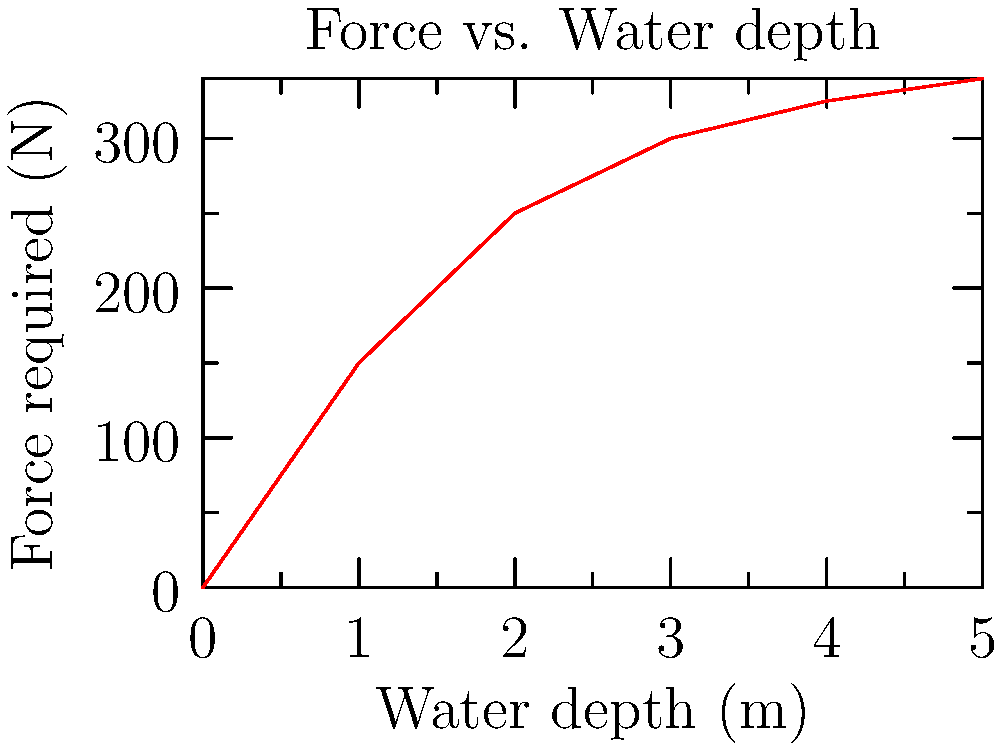Based on the graph showing the relationship between water depth and force required to operate a manual water pump, estimate the additional force needed to pump water from a depth of 4m compared to 2m. How might this information influence your decision-making in water conservation efforts at your lodge? To solve this problem, we need to follow these steps:

1. Identify the force required at 2m depth:
   From the graph, at x = 2m, y ≈ 250N

2. Identify the force required at 4m depth:
   From the graph, at x = 4m, y ≈ 325N

3. Calculate the difference in force:
   $\Delta F = F_{4m} - F_{2m} = 325N - 250N = 75N$

4. Interpret the result:
   An additional 75N of force is required to pump water from 4m compared to 2m.

5. Consider the implications for water conservation:
   - The increased force requirement at greater depths may influence the choice of pump type or location.
   - It might encourage the implementation of water-saving measures to reduce the need for pumping from greater depths.
   - The lodge might consider investing in more efficient pumping systems or alternative water sources to minimize energy expenditure and environmental impact.
Answer: 75N; may influence pump choice, encourage water-saving measures, and promote efficient system investments. 